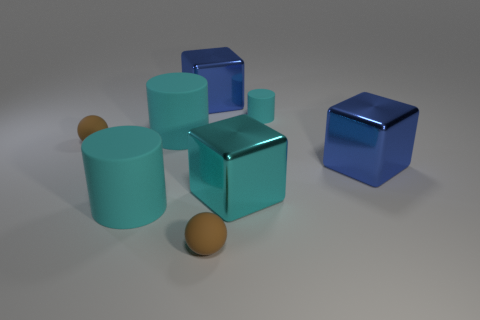Subtract all big cyan shiny blocks. How many blocks are left? 2 Add 1 blue cubes. How many objects exist? 9 Subtract all cubes. How many objects are left? 5 Subtract all cyan blocks. How many blocks are left? 2 Subtract all cyan cylinders. How many blue blocks are left? 2 Subtract 2 cyan cylinders. How many objects are left? 6 Subtract 2 cubes. How many cubes are left? 1 Subtract all green cylinders. Subtract all brown blocks. How many cylinders are left? 3 Subtract all small objects. Subtract all large cyan metallic objects. How many objects are left? 4 Add 1 blue objects. How many blue objects are left? 3 